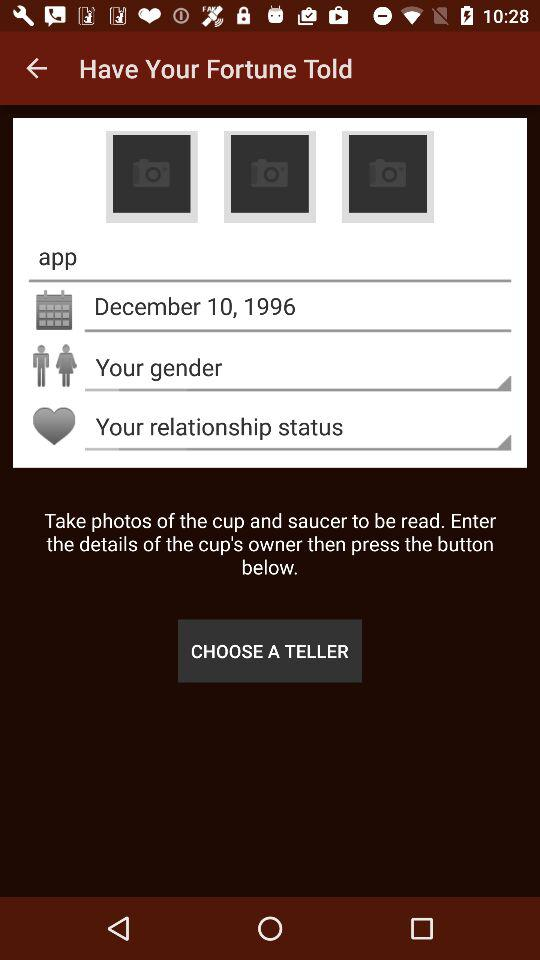How many photos are required to read the cup?
Answer the question using a single word or phrase. 3 